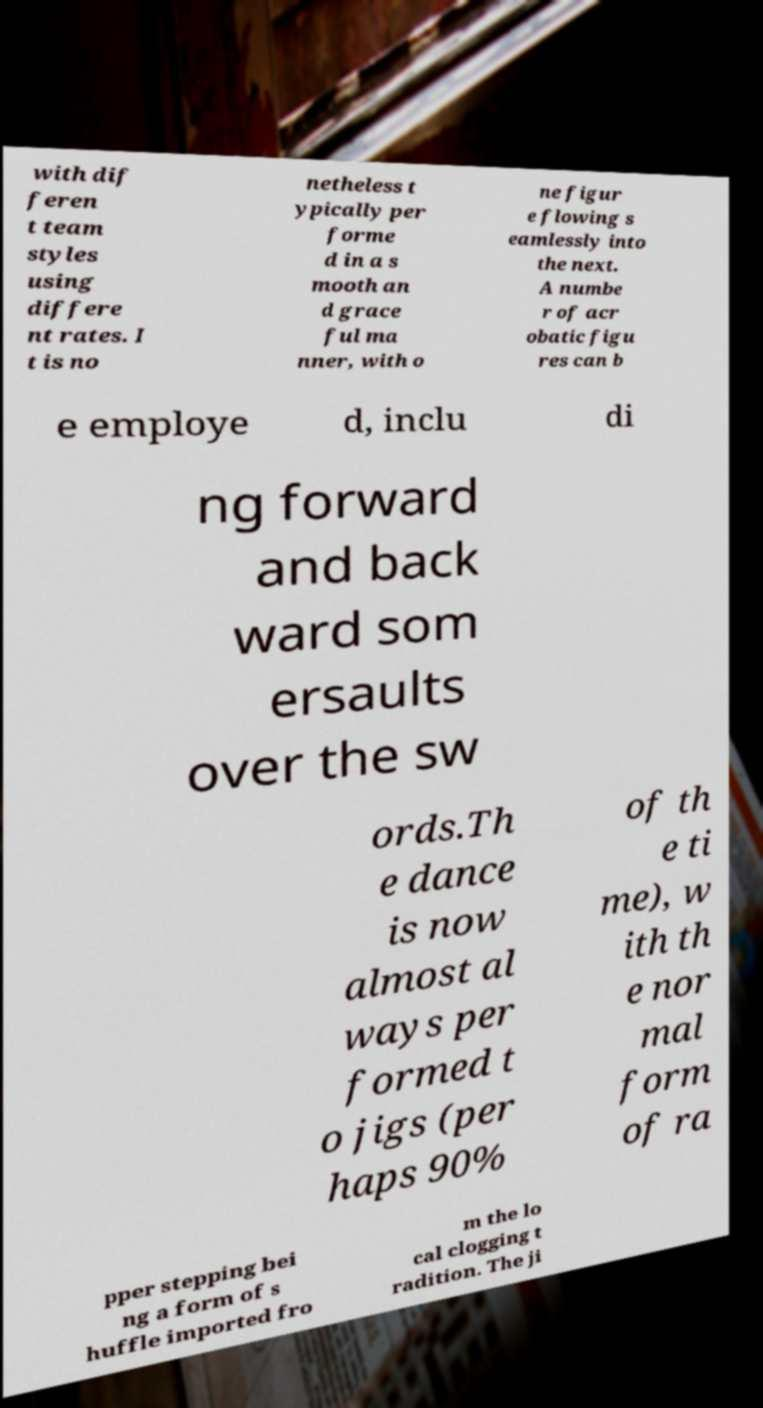Could you assist in decoding the text presented in this image and type it out clearly? with dif feren t team styles using differe nt rates. I t is no netheless t ypically per forme d in a s mooth an d grace ful ma nner, with o ne figur e flowing s eamlessly into the next. A numbe r of acr obatic figu res can b e employe d, inclu di ng forward and back ward som ersaults over the sw ords.Th e dance is now almost al ways per formed t o jigs (per haps 90% of th e ti me), w ith th e nor mal form of ra pper stepping bei ng a form of s huffle imported fro m the lo cal clogging t radition. The ji 